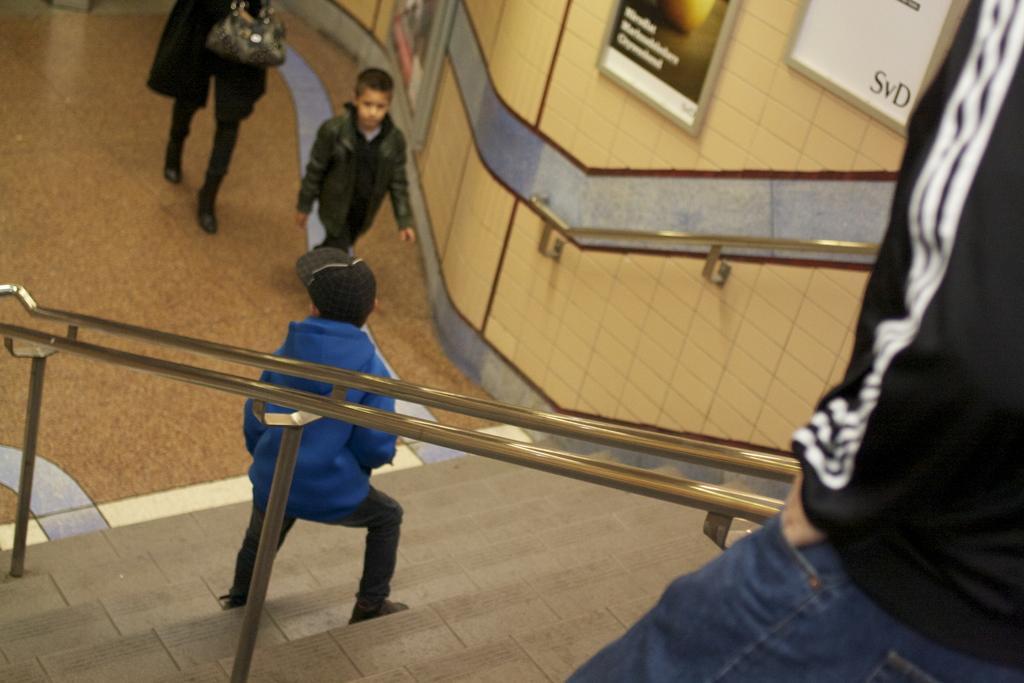In one or two sentences, can you explain what this image depicts? In this image I can see stairs in the front and on the both sides of it I can see railings. I can also see two children and two persons are standing. On the top right side of this image I can see few frames on the wall and on the top left side I can see a bag. 